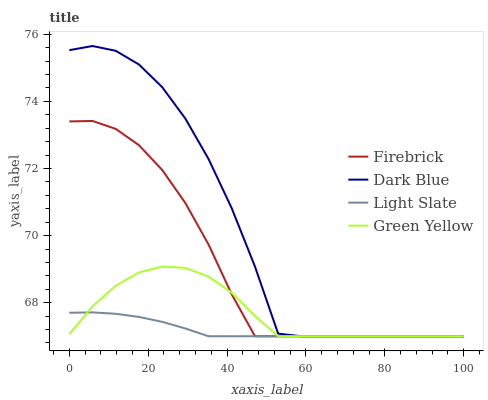Does Light Slate have the minimum area under the curve?
Answer yes or no. Yes. Does Dark Blue have the maximum area under the curve?
Answer yes or no. Yes. Does Firebrick have the minimum area under the curve?
Answer yes or no. No. Does Firebrick have the maximum area under the curve?
Answer yes or no. No. Is Light Slate the smoothest?
Answer yes or no. Yes. Is Dark Blue the roughest?
Answer yes or no. Yes. Is Firebrick the smoothest?
Answer yes or no. No. Is Firebrick the roughest?
Answer yes or no. No. Does Light Slate have the lowest value?
Answer yes or no. Yes. Does Dark Blue have the highest value?
Answer yes or no. Yes. Does Firebrick have the highest value?
Answer yes or no. No. Does Dark Blue intersect Green Yellow?
Answer yes or no. Yes. Is Dark Blue less than Green Yellow?
Answer yes or no. No. Is Dark Blue greater than Green Yellow?
Answer yes or no. No. 